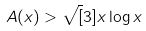<formula> <loc_0><loc_0><loc_500><loc_500>A ( x ) > \sqrt { [ } 3 ] { x \log x }</formula> 